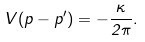Convert formula to latex. <formula><loc_0><loc_0><loc_500><loc_500>V ( p - p ^ { \prime } ) = - \frac { \kappa } { 2 \pi } .</formula> 